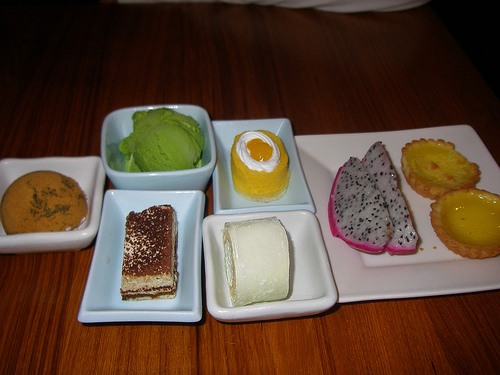<image>
Is the ice cream to the right of the cookie? Yes. From this viewpoint, the ice cream is positioned to the right side relative to the cookie. 